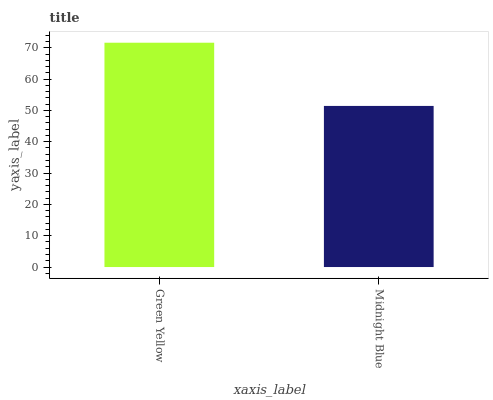Is Midnight Blue the minimum?
Answer yes or no. Yes. Is Green Yellow the maximum?
Answer yes or no. Yes. Is Midnight Blue the maximum?
Answer yes or no. No. Is Green Yellow greater than Midnight Blue?
Answer yes or no. Yes. Is Midnight Blue less than Green Yellow?
Answer yes or no. Yes. Is Midnight Blue greater than Green Yellow?
Answer yes or no. No. Is Green Yellow less than Midnight Blue?
Answer yes or no. No. Is Green Yellow the high median?
Answer yes or no. Yes. Is Midnight Blue the low median?
Answer yes or no. Yes. Is Midnight Blue the high median?
Answer yes or no. No. Is Green Yellow the low median?
Answer yes or no. No. 